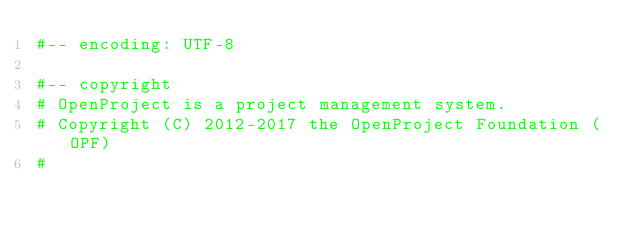<code> <loc_0><loc_0><loc_500><loc_500><_Ruby_>#-- encoding: UTF-8

#-- copyright
# OpenProject is a project management system.
# Copyright (C) 2012-2017 the OpenProject Foundation (OPF)
#</code> 